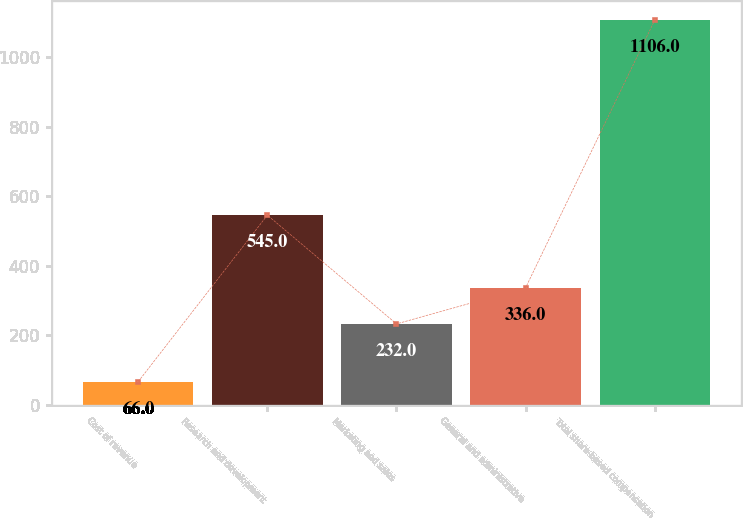Convert chart to OTSL. <chart><loc_0><loc_0><loc_500><loc_500><bar_chart><fcel>Cost of revenue<fcel>Research and development<fcel>Marketing and sales<fcel>General and administrative<fcel>Total share-based compensation<nl><fcel>66<fcel>545<fcel>232<fcel>336<fcel>1106<nl></chart> 